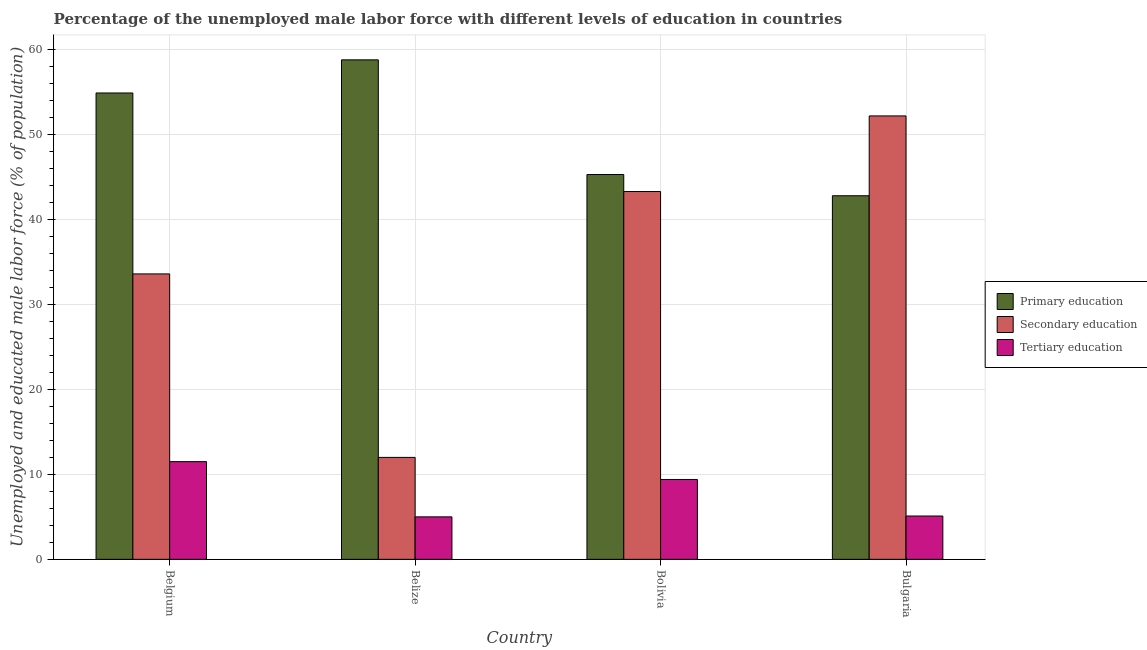How many different coloured bars are there?
Ensure brevity in your answer.  3. Are the number of bars on each tick of the X-axis equal?
Provide a succinct answer. Yes. What is the label of the 4th group of bars from the left?
Your answer should be compact. Bulgaria. In how many cases, is the number of bars for a given country not equal to the number of legend labels?
Your response must be concise. 0. What is the percentage of male labor force who received secondary education in Bulgaria?
Offer a very short reply. 52.2. Across all countries, what is the maximum percentage of male labor force who received tertiary education?
Provide a succinct answer. 11.5. Across all countries, what is the minimum percentage of male labor force who received primary education?
Keep it short and to the point. 42.8. In which country was the percentage of male labor force who received primary education maximum?
Ensure brevity in your answer.  Belize. In which country was the percentage of male labor force who received secondary education minimum?
Give a very brief answer. Belize. What is the total percentage of male labor force who received secondary education in the graph?
Your response must be concise. 141.1. What is the difference between the percentage of male labor force who received secondary education in Belgium and that in Bolivia?
Offer a very short reply. -9.7. What is the difference between the percentage of male labor force who received tertiary education in Bolivia and the percentage of male labor force who received primary education in Bulgaria?
Provide a short and direct response. -33.4. What is the average percentage of male labor force who received tertiary education per country?
Your response must be concise. 7.75. What is the difference between the percentage of male labor force who received tertiary education and percentage of male labor force who received primary education in Belgium?
Provide a short and direct response. -43.4. In how many countries, is the percentage of male labor force who received tertiary education greater than 32 %?
Ensure brevity in your answer.  0. What is the ratio of the percentage of male labor force who received tertiary education in Bolivia to that in Bulgaria?
Offer a very short reply. 1.84. Is the percentage of male labor force who received tertiary education in Belize less than that in Bulgaria?
Your answer should be compact. Yes. Is the difference between the percentage of male labor force who received secondary education in Belgium and Belize greater than the difference between the percentage of male labor force who received primary education in Belgium and Belize?
Keep it short and to the point. Yes. What is the difference between the highest and the second highest percentage of male labor force who received tertiary education?
Your answer should be compact. 2.1. What is the difference between the highest and the lowest percentage of male labor force who received primary education?
Offer a very short reply. 16. What does the 2nd bar from the left in Bolivia represents?
Offer a very short reply. Secondary education. What does the 1st bar from the right in Bolivia represents?
Ensure brevity in your answer.  Tertiary education. Is it the case that in every country, the sum of the percentage of male labor force who received primary education and percentage of male labor force who received secondary education is greater than the percentage of male labor force who received tertiary education?
Provide a short and direct response. Yes. How many bars are there?
Give a very brief answer. 12. Are all the bars in the graph horizontal?
Provide a short and direct response. No. How many countries are there in the graph?
Give a very brief answer. 4. What is the difference between two consecutive major ticks on the Y-axis?
Your response must be concise. 10. Does the graph contain grids?
Make the answer very short. Yes. How are the legend labels stacked?
Your response must be concise. Vertical. What is the title of the graph?
Your response must be concise. Percentage of the unemployed male labor force with different levels of education in countries. What is the label or title of the Y-axis?
Offer a very short reply. Unemployed and educated male labor force (% of population). What is the Unemployed and educated male labor force (% of population) in Primary education in Belgium?
Ensure brevity in your answer.  54.9. What is the Unemployed and educated male labor force (% of population) of Secondary education in Belgium?
Provide a short and direct response. 33.6. What is the Unemployed and educated male labor force (% of population) in Tertiary education in Belgium?
Offer a terse response. 11.5. What is the Unemployed and educated male labor force (% of population) of Primary education in Belize?
Your answer should be very brief. 58.8. What is the Unemployed and educated male labor force (% of population) in Primary education in Bolivia?
Your answer should be very brief. 45.3. What is the Unemployed and educated male labor force (% of population) of Secondary education in Bolivia?
Offer a very short reply. 43.3. What is the Unemployed and educated male labor force (% of population) in Tertiary education in Bolivia?
Keep it short and to the point. 9.4. What is the Unemployed and educated male labor force (% of population) of Primary education in Bulgaria?
Provide a succinct answer. 42.8. What is the Unemployed and educated male labor force (% of population) of Secondary education in Bulgaria?
Your answer should be very brief. 52.2. What is the Unemployed and educated male labor force (% of population) of Tertiary education in Bulgaria?
Provide a succinct answer. 5.1. Across all countries, what is the maximum Unemployed and educated male labor force (% of population) in Primary education?
Ensure brevity in your answer.  58.8. Across all countries, what is the maximum Unemployed and educated male labor force (% of population) of Secondary education?
Your response must be concise. 52.2. Across all countries, what is the minimum Unemployed and educated male labor force (% of population) in Primary education?
Your response must be concise. 42.8. Across all countries, what is the minimum Unemployed and educated male labor force (% of population) of Secondary education?
Ensure brevity in your answer.  12. What is the total Unemployed and educated male labor force (% of population) of Primary education in the graph?
Your answer should be very brief. 201.8. What is the total Unemployed and educated male labor force (% of population) in Secondary education in the graph?
Your answer should be very brief. 141.1. What is the difference between the Unemployed and educated male labor force (% of population) of Primary education in Belgium and that in Belize?
Give a very brief answer. -3.9. What is the difference between the Unemployed and educated male labor force (% of population) of Secondary education in Belgium and that in Belize?
Give a very brief answer. 21.6. What is the difference between the Unemployed and educated male labor force (% of population) of Tertiary education in Belgium and that in Belize?
Keep it short and to the point. 6.5. What is the difference between the Unemployed and educated male labor force (% of population) in Secondary education in Belgium and that in Bolivia?
Make the answer very short. -9.7. What is the difference between the Unemployed and educated male labor force (% of population) in Tertiary education in Belgium and that in Bolivia?
Your answer should be compact. 2.1. What is the difference between the Unemployed and educated male labor force (% of population) of Secondary education in Belgium and that in Bulgaria?
Provide a short and direct response. -18.6. What is the difference between the Unemployed and educated male labor force (% of population) of Tertiary education in Belgium and that in Bulgaria?
Offer a very short reply. 6.4. What is the difference between the Unemployed and educated male labor force (% of population) in Secondary education in Belize and that in Bolivia?
Offer a very short reply. -31.3. What is the difference between the Unemployed and educated male labor force (% of population) of Tertiary education in Belize and that in Bolivia?
Keep it short and to the point. -4.4. What is the difference between the Unemployed and educated male labor force (% of population) in Secondary education in Belize and that in Bulgaria?
Provide a succinct answer. -40.2. What is the difference between the Unemployed and educated male labor force (% of population) in Tertiary education in Belize and that in Bulgaria?
Provide a succinct answer. -0.1. What is the difference between the Unemployed and educated male labor force (% of population) in Primary education in Belgium and the Unemployed and educated male labor force (% of population) in Secondary education in Belize?
Make the answer very short. 42.9. What is the difference between the Unemployed and educated male labor force (% of population) in Primary education in Belgium and the Unemployed and educated male labor force (% of population) in Tertiary education in Belize?
Give a very brief answer. 49.9. What is the difference between the Unemployed and educated male labor force (% of population) in Secondary education in Belgium and the Unemployed and educated male labor force (% of population) in Tertiary education in Belize?
Offer a terse response. 28.6. What is the difference between the Unemployed and educated male labor force (% of population) in Primary education in Belgium and the Unemployed and educated male labor force (% of population) in Secondary education in Bolivia?
Offer a terse response. 11.6. What is the difference between the Unemployed and educated male labor force (% of population) in Primary education in Belgium and the Unemployed and educated male labor force (% of population) in Tertiary education in Bolivia?
Make the answer very short. 45.5. What is the difference between the Unemployed and educated male labor force (% of population) of Secondary education in Belgium and the Unemployed and educated male labor force (% of population) of Tertiary education in Bolivia?
Make the answer very short. 24.2. What is the difference between the Unemployed and educated male labor force (% of population) of Primary education in Belgium and the Unemployed and educated male labor force (% of population) of Tertiary education in Bulgaria?
Your response must be concise. 49.8. What is the difference between the Unemployed and educated male labor force (% of population) of Primary education in Belize and the Unemployed and educated male labor force (% of population) of Secondary education in Bolivia?
Make the answer very short. 15.5. What is the difference between the Unemployed and educated male labor force (% of population) in Primary education in Belize and the Unemployed and educated male labor force (% of population) in Tertiary education in Bolivia?
Your response must be concise. 49.4. What is the difference between the Unemployed and educated male labor force (% of population) in Primary education in Belize and the Unemployed and educated male labor force (% of population) in Secondary education in Bulgaria?
Keep it short and to the point. 6.6. What is the difference between the Unemployed and educated male labor force (% of population) in Primary education in Belize and the Unemployed and educated male labor force (% of population) in Tertiary education in Bulgaria?
Provide a short and direct response. 53.7. What is the difference between the Unemployed and educated male labor force (% of population) of Primary education in Bolivia and the Unemployed and educated male labor force (% of population) of Secondary education in Bulgaria?
Keep it short and to the point. -6.9. What is the difference between the Unemployed and educated male labor force (% of population) in Primary education in Bolivia and the Unemployed and educated male labor force (% of population) in Tertiary education in Bulgaria?
Offer a terse response. 40.2. What is the difference between the Unemployed and educated male labor force (% of population) of Secondary education in Bolivia and the Unemployed and educated male labor force (% of population) of Tertiary education in Bulgaria?
Offer a terse response. 38.2. What is the average Unemployed and educated male labor force (% of population) in Primary education per country?
Offer a terse response. 50.45. What is the average Unemployed and educated male labor force (% of population) in Secondary education per country?
Give a very brief answer. 35.27. What is the average Unemployed and educated male labor force (% of population) of Tertiary education per country?
Your response must be concise. 7.75. What is the difference between the Unemployed and educated male labor force (% of population) of Primary education and Unemployed and educated male labor force (% of population) of Secondary education in Belgium?
Your answer should be compact. 21.3. What is the difference between the Unemployed and educated male labor force (% of population) in Primary education and Unemployed and educated male labor force (% of population) in Tertiary education in Belgium?
Keep it short and to the point. 43.4. What is the difference between the Unemployed and educated male labor force (% of population) of Secondary education and Unemployed and educated male labor force (% of population) of Tertiary education in Belgium?
Offer a terse response. 22.1. What is the difference between the Unemployed and educated male labor force (% of population) of Primary education and Unemployed and educated male labor force (% of population) of Secondary education in Belize?
Your answer should be very brief. 46.8. What is the difference between the Unemployed and educated male labor force (% of population) in Primary education and Unemployed and educated male labor force (% of population) in Tertiary education in Belize?
Offer a terse response. 53.8. What is the difference between the Unemployed and educated male labor force (% of population) of Secondary education and Unemployed and educated male labor force (% of population) of Tertiary education in Belize?
Offer a very short reply. 7. What is the difference between the Unemployed and educated male labor force (% of population) in Primary education and Unemployed and educated male labor force (% of population) in Secondary education in Bolivia?
Your answer should be compact. 2. What is the difference between the Unemployed and educated male labor force (% of population) of Primary education and Unemployed and educated male labor force (% of population) of Tertiary education in Bolivia?
Your response must be concise. 35.9. What is the difference between the Unemployed and educated male labor force (% of population) of Secondary education and Unemployed and educated male labor force (% of population) of Tertiary education in Bolivia?
Give a very brief answer. 33.9. What is the difference between the Unemployed and educated male labor force (% of population) of Primary education and Unemployed and educated male labor force (% of population) of Tertiary education in Bulgaria?
Make the answer very short. 37.7. What is the difference between the Unemployed and educated male labor force (% of population) of Secondary education and Unemployed and educated male labor force (% of population) of Tertiary education in Bulgaria?
Your answer should be compact. 47.1. What is the ratio of the Unemployed and educated male labor force (% of population) in Primary education in Belgium to that in Belize?
Provide a succinct answer. 0.93. What is the ratio of the Unemployed and educated male labor force (% of population) of Secondary education in Belgium to that in Belize?
Offer a terse response. 2.8. What is the ratio of the Unemployed and educated male labor force (% of population) in Tertiary education in Belgium to that in Belize?
Provide a succinct answer. 2.3. What is the ratio of the Unemployed and educated male labor force (% of population) in Primary education in Belgium to that in Bolivia?
Keep it short and to the point. 1.21. What is the ratio of the Unemployed and educated male labor force (% of population) in Secondary education in Belgium to that in Bolivia?
Your response must be concise. 0.78. What is the ratio of the Unemployed and educated male labor force (% of population) in Tertiary education in Belgium to that in Bolivia?
Keep it short and to the point. 1.22. What is the ratio of the Unemployed and educated male labor force (% of population) in Primary education in Belgium to that in Bulgaria?
Provide a succinct answer. 1.28. What is the ratio of the Unemployed and educated male labor force (% of population) in Secondary education in Belgium to that in Bulgaria?
Give a very brief answer. 0.64. What is the ratio of the Unemployed and educated male labor force (% of population) in Tertiary education in Belgium to that in Bulgaria?
Ensure brevity in your answer.  2.25. What is the ratio of the Unemployed and educated male labor force (% of population) of Primary education in Belize to that in Bolivia?
Make the answer very short. 1.3. What is the ratio of the Unemployed and educated male labor force (% of population) of Secondary education in Belize to that in Bolivia?
Provide a short and direct response. 0.28. What is the ratio of the Unemployed and educated male labor force (% of population) of Tertiary education in Belize to that in Bolivia?
Offer a terse response. 0.53. What is the ratio of the Unemployed and educated male labor force (% of population) of Primary education in Belize to that in Bulgaria?
Your answer should be very brief. 1.37. What is the ratio of the Unemployed and educated male labor force (% of population) of Secondary education in Belize to that in Bulgaria?
Offer a very short reply. 0.23. What is the ratio of the Unemployed and educated male labor force (% of population) in Tertiary education in Belize to that in Bulgaria?
Offer a very short reply. 0.98. What is the ratio of the Unemployed and educated male labor force (% of population) of Primary education in Bolivia to that in Bulgaria?
Your answer should be very brief. 1.06. What is the ratio of the Unemployed and educated male labor force (% of population) of Secondary education in Bolivia to that in Bulgaria?
Offer a terse response. 0.83. What is the ratio of the Unemployed and educated male labor force (% of population) of Tertiary education in Bolivia to that in Bulgaria?
Keep it short and to the point. 1.84. What is the difference between the highest and the second highest Unemployed and educated male labor force (% of population) of Primary education?
Ensure brevity in your answer.  3.9. What is the difference between the highest and the second highest Unemployed and educated male labor force (% of population) in Secondary education?
Provide a short and direct response. 8.9. What is the difference between the highest and the second highest Unemployed and educated male labor force (% of population) of Tertiary education?
Make the answer very short. 2.1. What is the difference between the highest and the lowest Unemployed and educated male labor force (% of population) in Primary education?
Your answer should be very brief. 16. What is the difference between the highest and the lowest Unemployed and educated male labor force (% of population) in Secondary education?
Ensure brevity in your answer.  40.2. What is the difference between the highest and the lowest Unemployed and educated male labor force (% of population) in Tertiary education?
Keep it short and to the point. 6.5. 